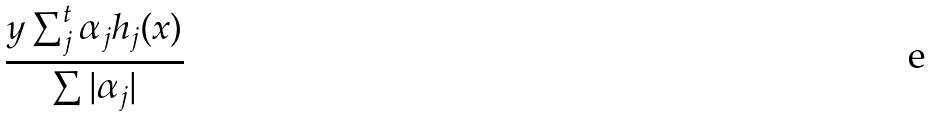Convert formula to latex. <formula><loc_0><loc_0><loc_500><loc_500>\frac { y \sum _ { j } ^ { t } \alpha _ { j } h _ { j } ( x ) } { \sum | \alpha _ { j } | }</formula> 